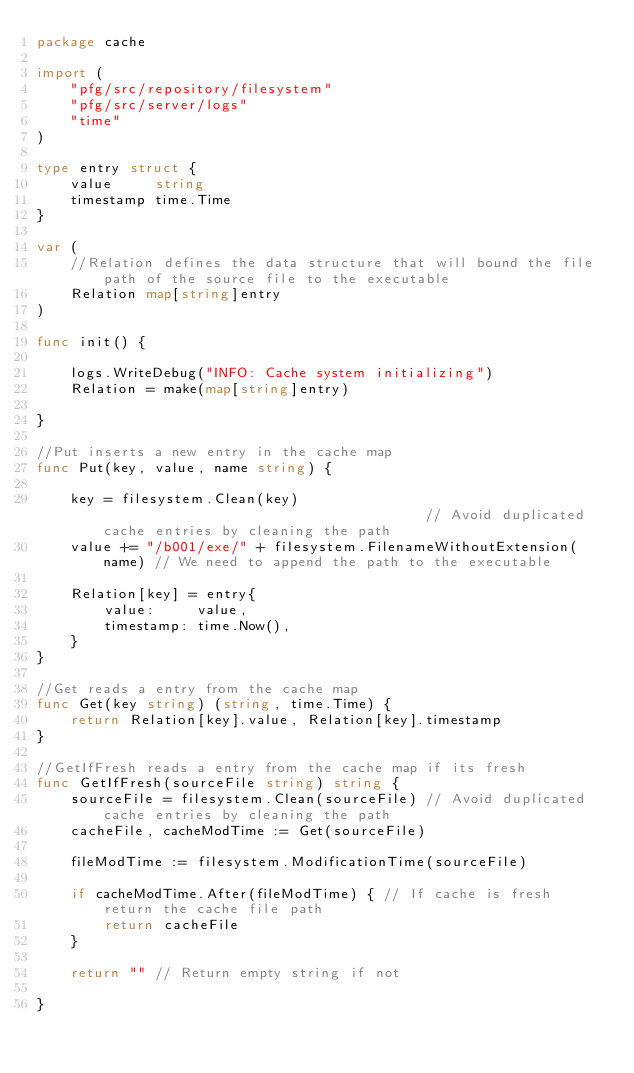Convert code to text. <code><loc_0><loc_0><loc_500><loc_500><_Go_>package cache

import (
	"pfg/src/repository/filesystem"
	"pfg/src/server/logs"
	"time"
)

type entry struct {
	value     string
	timestamp time.Time
}

var (
	//Relation defines the data structure that will bound the file path of the source file to the executable
	Relation map[string]entry
)

func init() {

	logs.WriteDebug("INFO: Cache system initializing")
	Relation = make(map[string]entry)

}

//Put inserts a new entry in the cache map
func Put(key, value, name string) {

	key = filesystem.Clean(key)                                       // Avoid duplicated cache entries by cleaning the path
	value += "/b001/exe/" + filesystem.FilenameWithoutExtension(name) // We need to append the path to the executable

	Relation[key] = entry{
		value:     value,
		timestamp: time.Now(),
	}
}

//Get reads a entry from the cache map
func Get(key string) (string, time.Time) {
	return Relation[key].value, Relation[key].timestamp
}

//GetIfFresh reads a entry from the cache map if its fresh
func GetIfFresh(sourceFile string) string {
	sourceFile = filesystem.Clean(sourceFile) // Avoid duplicated cache entries by cleaning the path
	cacheFile, cacheModTime := Get(sourceFile)

	fileModTime := filesystem.ModificationTime(sourceFile)

	if cacheModTime.After(fileModTime) { // If cache is fresh return the cache file path
		return cacheFile
	}

	return "" // Return empty string if not

}
</code> 